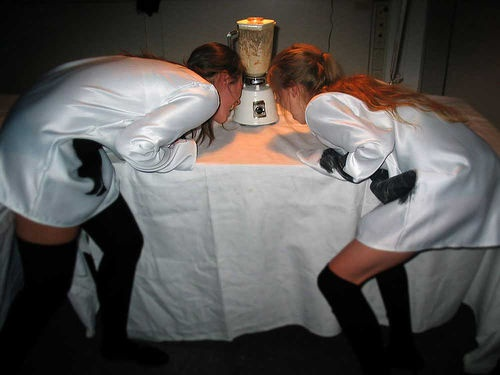Describe the objects in this image and their specific colors. I can see people in black, darkgray, lightgray, and gray tones, people in black, darkgray, gray, and maroon tones, and dining table in black, tan, maroon, and gray tones in this image. 